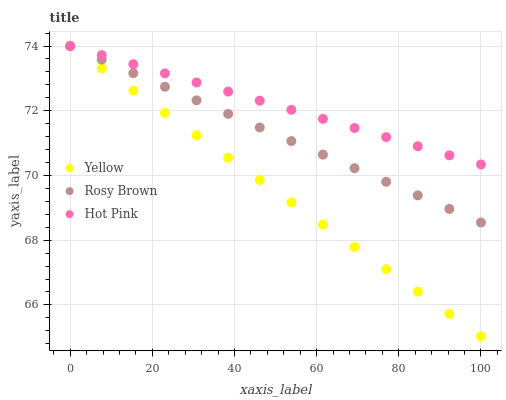Does Yellow have the minimum area under the curve?
Answer yes or no. Yes. Does Hot Pink have the maximum area under the curve?
Answer yes or no. Yes. Does Hot Pink have the minimum area under the curve?
Answer yes or no. No. Does Yellow have the maximum area under the curve?
Answer yes or no. No. Is Hot Pink the smoothest?
Answer yes or no. Yes. Is Yellow the roughest?
Answer yes or no. Yes. Is Yellow the smoothest?
Answer yes or no. No. Is Hot Pink the roughest?
Answer yes or no. No. Does Yellow have the lowest value?
Answer yes or no. Yes. Does Hot Pink have the lowest value?
Answer yes or no. No. Does Hot Pink have the highest value?
Answer yes or no. Yes. Does Yellow intersect Rosy Brown?
Answer yes or no. Yes. Is Yellow less than Rosy Brown?
Answer yes or no. No. Is Yellow greater than Rosy Brown?
Answer yes or no. No. 